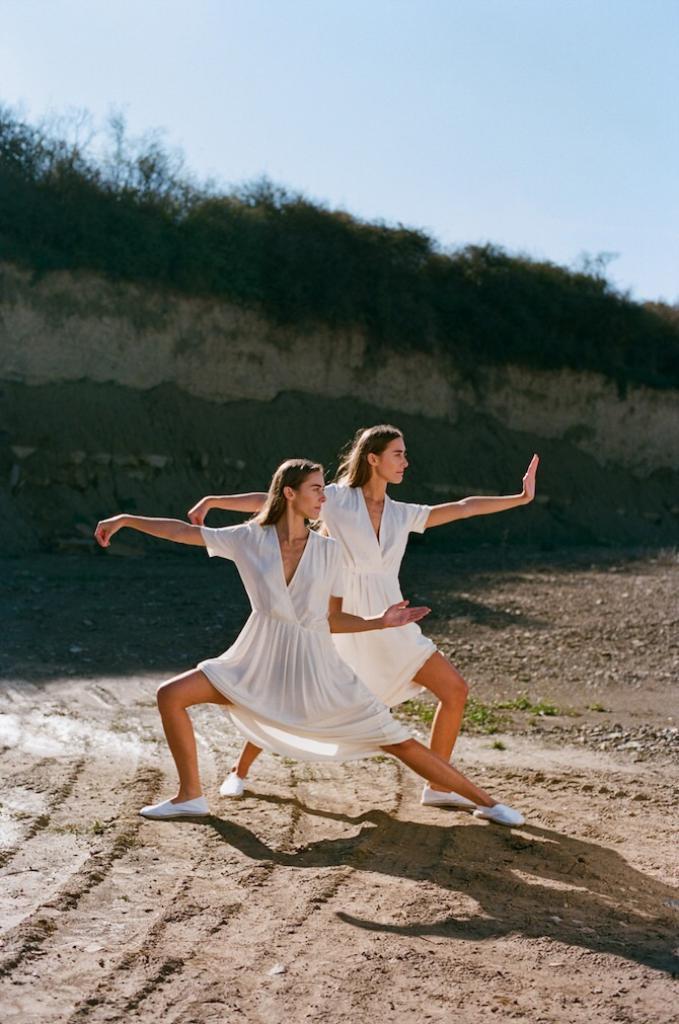In one or two sentences, can you explain what this image depicts? In this picture, we can see there are two women in the white dress standing on the path and behind the women there are plants and a sky. 